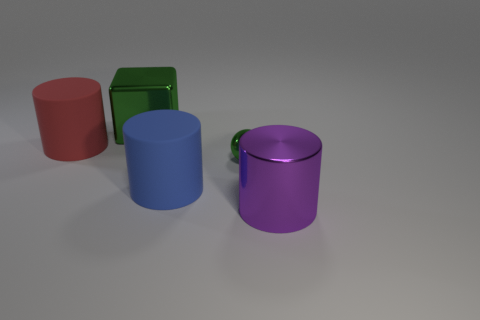There is a cylinder that is behind the small green ball; what material is it?
Your answer should be compact. Rubber. There is another metal thing that is the same size as the purple shiny object; what is its shape?
Offer a terse response. Cube. Is there a purple thing of the same shape as the blue matte object?
Provide a short and direct response. Yes. Does the green ball have the same material as the large purple cylinder that is on the right side of the green metal block?
Make the answer very short. Yes. What material is the object that is on the left side of the large metal object that is behind the large purple cylinder?
Your answer should be very brief. Rubber. Are there more objects in front of the big blue rubber object than balls?
Give a very brief answer. No. Are there any big cyan shiny balls?
Offer a very short reply. No. What color is the big metallic thing that is behind the small shiny thing?
Offer a terse response. Green. What is the material of the red cylinder that is the same size as the blue thing?
Your response must be concise. Rubber. What number of other objects are the same material as the big blue cylinder?
Your answer should be compact. 1. 